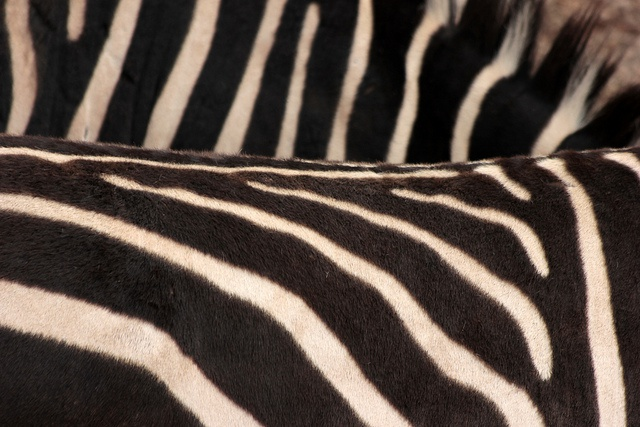Describe the objects in this image and their specific colors. I can see zebra in black, lightgray, and tan tones and zebra in black, tan, and gray tones in this image. 